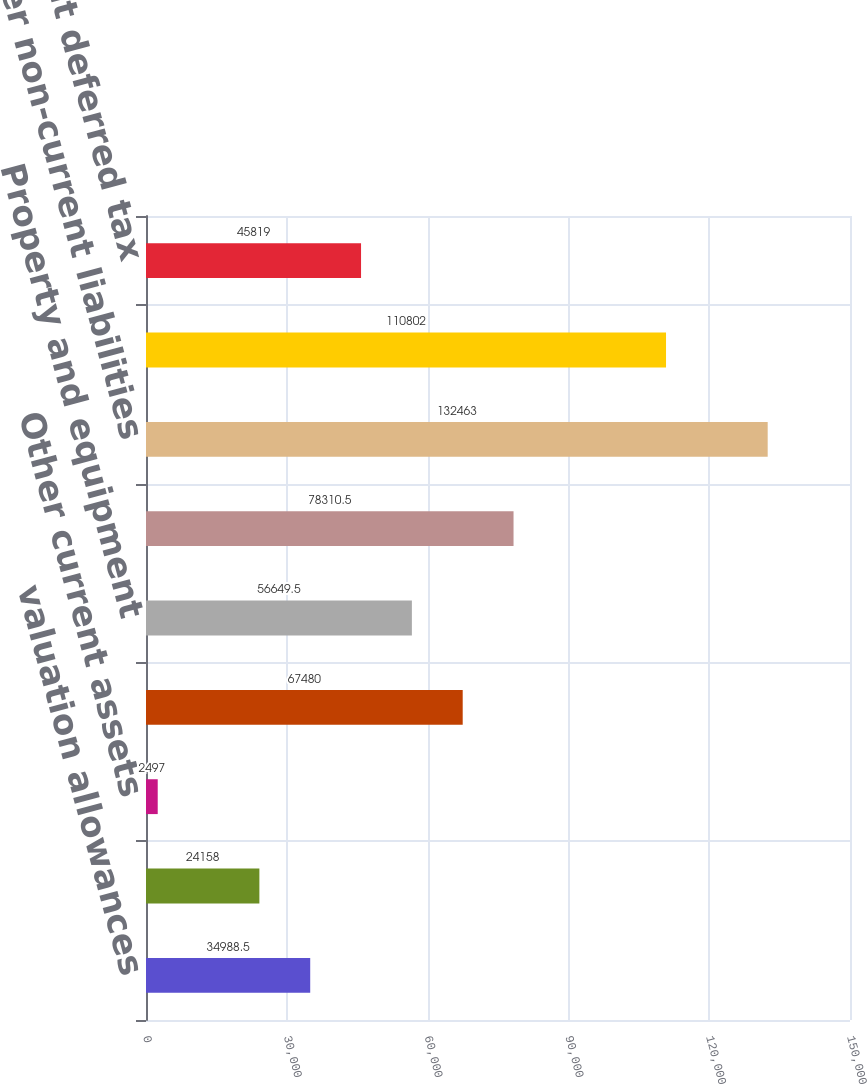Convert chart. <chart><loc_0><loc_0><loc_500><loc_500><bar_chart><fcel>valuation allowances<fcel>Uniform capitalization<fcel>Other current assets<fcel>Current deferred income tax<fcel>Property and equipment<fcel>Stock-based compensation<fcel>Other non-current liabilities<fcel>Net operating losses of<fcel>Total non-current deferred tax<nl><fcel>34988.5<fcel>24158<fcel>2497<fcel>67480<fcel>56649.5<fcel>78310.5<fcel>132463<fcel>110802<fcel>45819<nl></chart> 